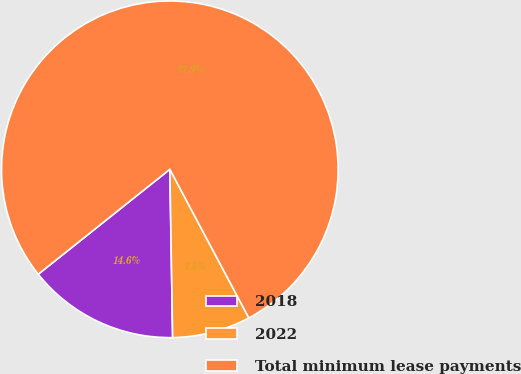Convert chart to OTSL. <chart><loc_0><loc_0><loc_500><loc_500><pie_chart><fcel>2018<fcel>2022<fcel>Total minimum lease payments<nl><fcel>14.55%<fcel>7.51%<fcel>77.93%<nl></chart> 